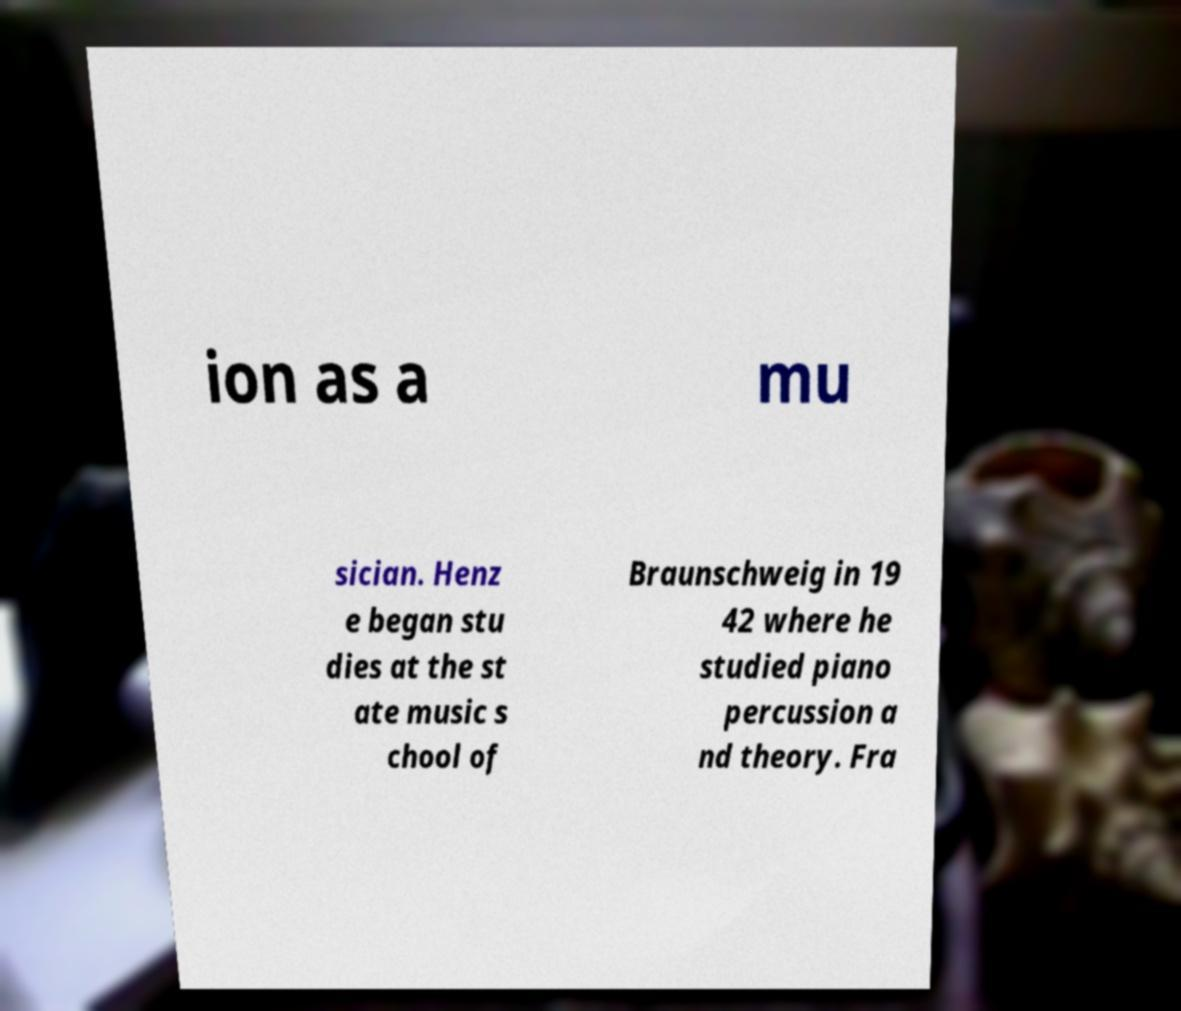There's text embedded in this image that I need extracted. Can you transcribe it verbatim? ion as a mu sician. Henz e began stu dies at the st ate music s chool of Braunschweig in 19 42 where he studied piano percussion a nd theory. Fra 